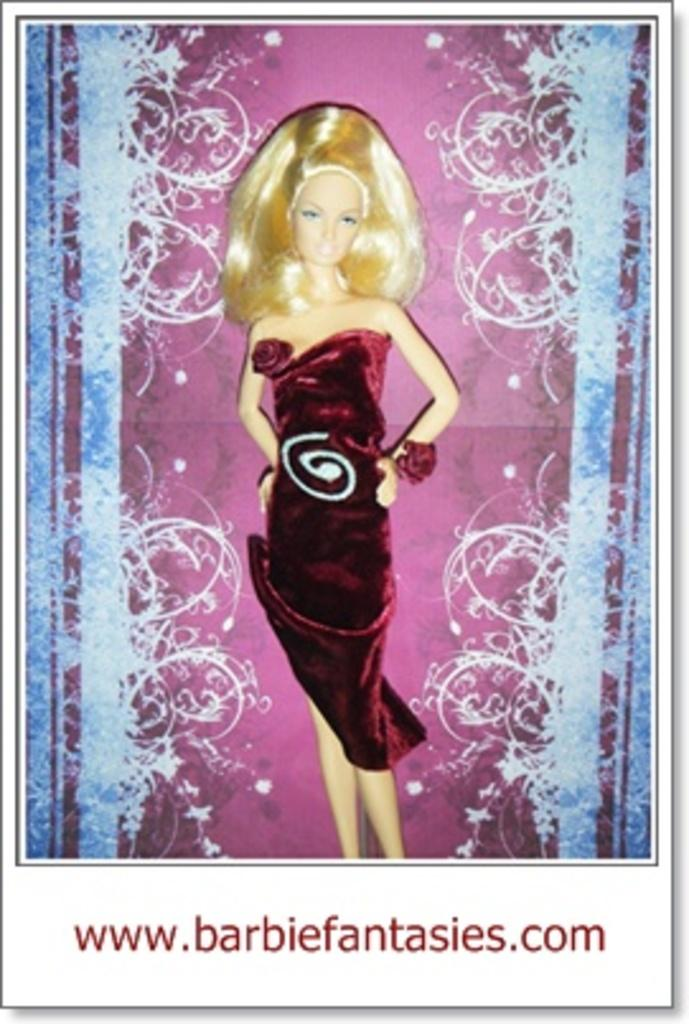What is the main subject of the image? The image contains a photograph. What can be seen in the photograph? There is a Barbie doll in the photograph. What is the Barbie doll wearing? The Barbie doll is wearing a frock. Is there any text in the photograph? Yes, there is red text at the bottom of the photograph. How many mittens can be seen on the Barbie doll in the image? There are no mittens present on the Barbie doll in the image; it is wearing a frock. Is there a rabbit visible in the photograph? No, there is no rabbit present in the photograph; it features a Barbie doll wearing a frock. 